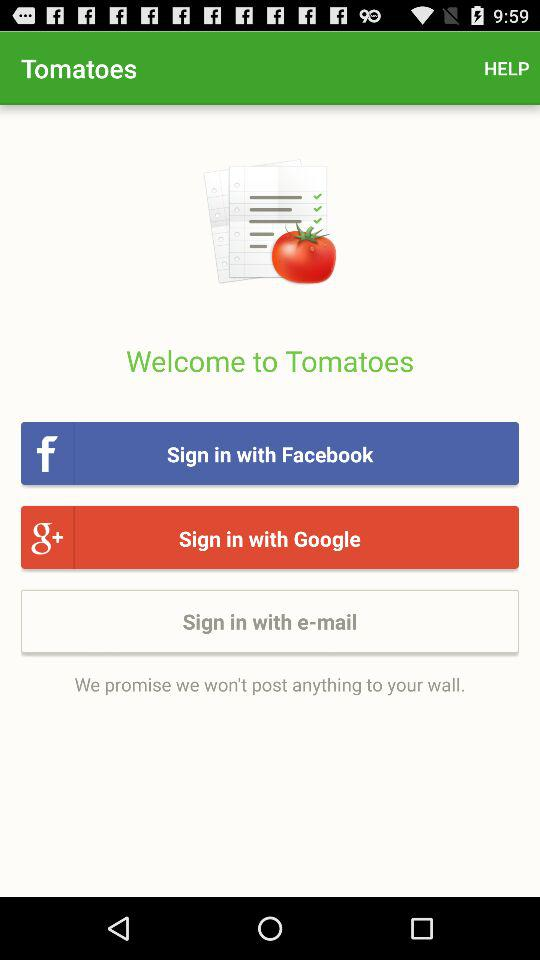Which account are you going to sign in with? You are going to sign in with your "Facebook", "Google" or "e-mail" account. 